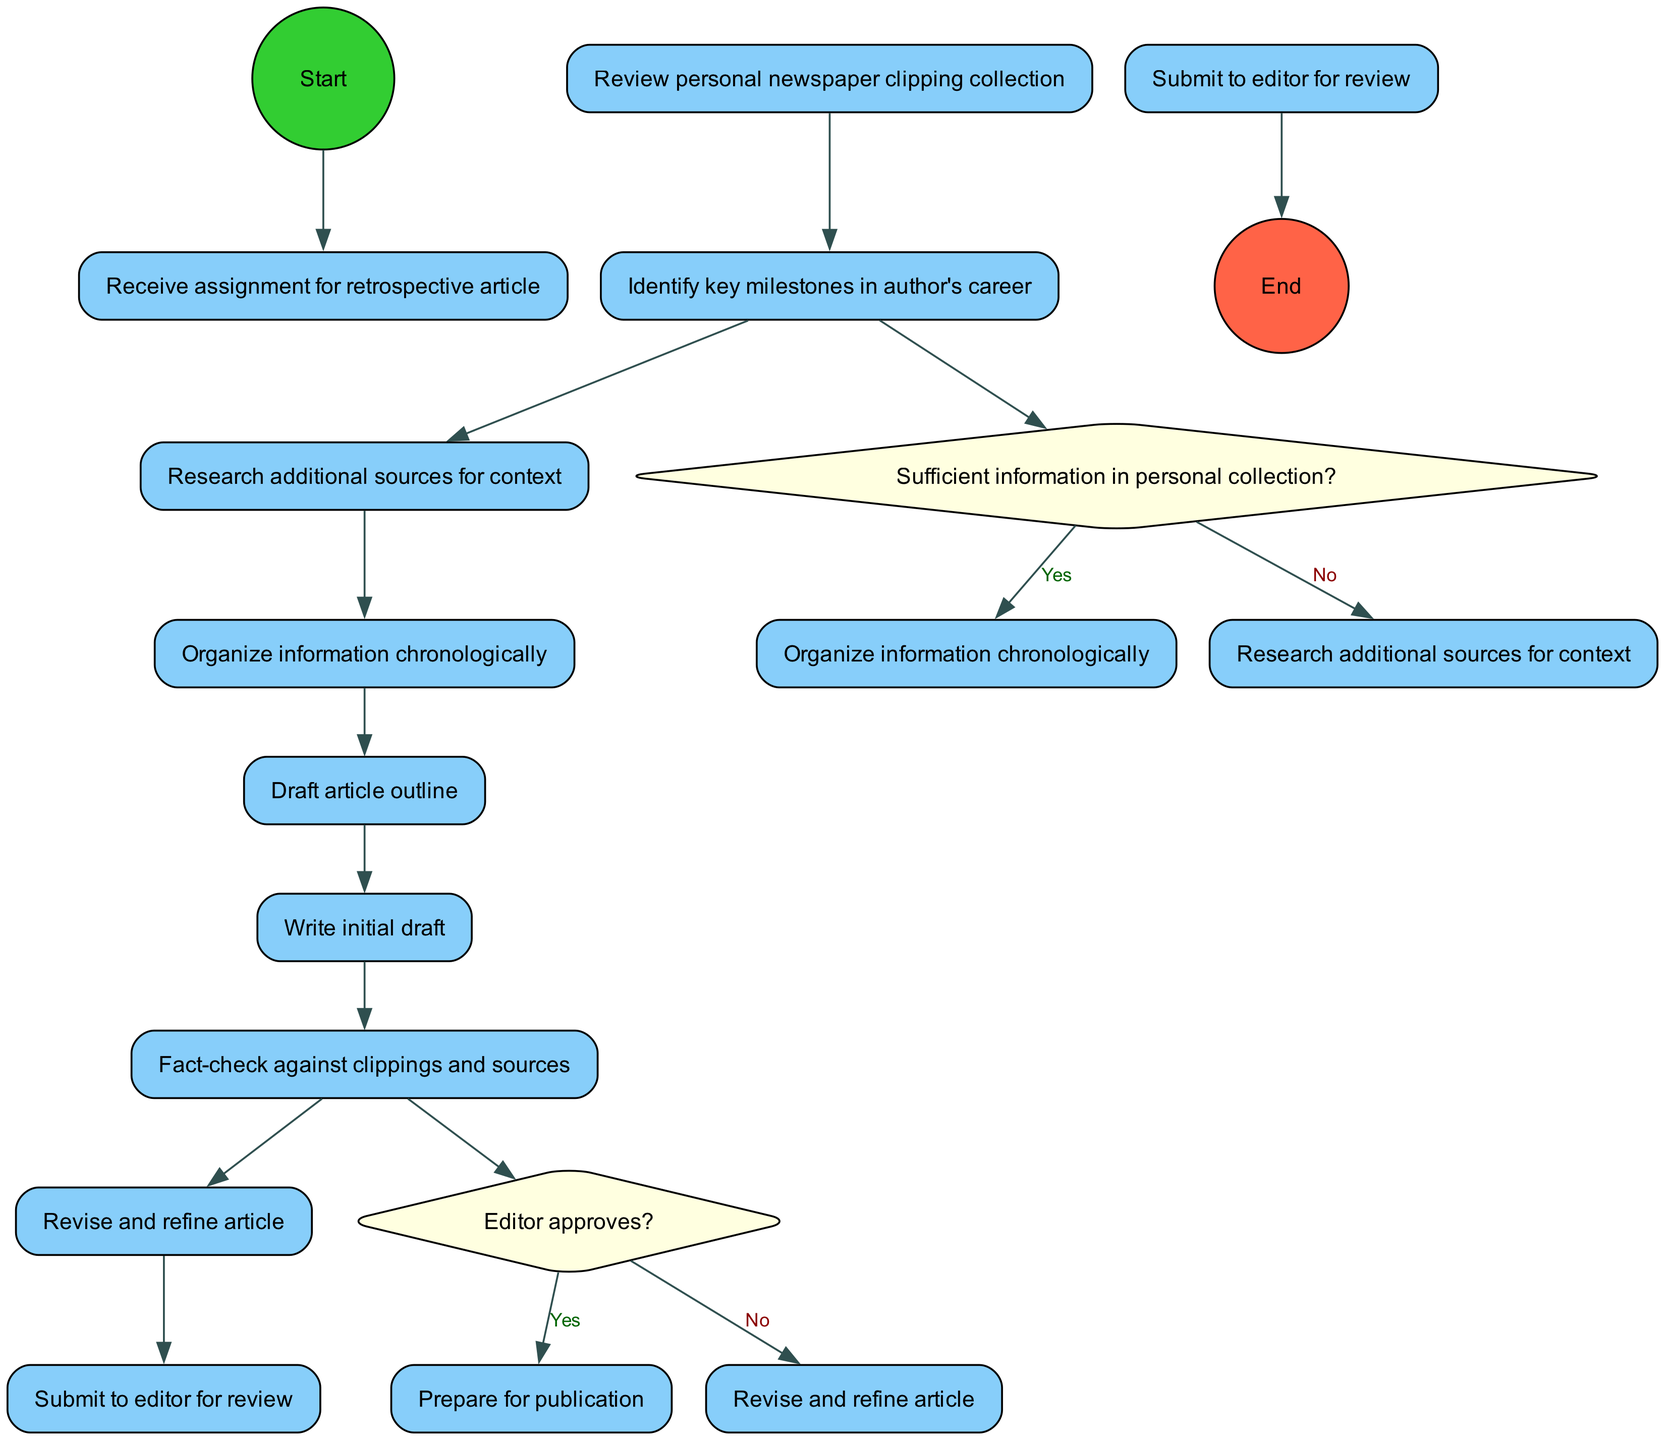What is the starting node of the diagram? The starting node is labeled "Receive assignment for retrospective article," which signifies the first step in the workflow.
Answer: Receive assignment for retrospective article How many activities are there in the workflow? There are nine activities listed in the diagram, each representing a distinct step in the process of writing the retrospective article.
Answer: 9 What is the first decision point in the diagram? The first decision point is the question "Sufficient information in personal collection?" which indicates whether to proceed with organizing the collected information or to research additional sources.
Answer: Sufficient information in personal collection? What happens if the editor does not approve the article? If the editor does not approve the article, the workflow directs the author to "Revise and refine article," indicating that changes must be made before resubmission.
Answer: Revise and refine article How does one handle insufficient information in the personal collection? If there is insufficient information in the personal collection, the author is directed to "Research additional sources for context," leading to further investigation before organizing the information.
Answer: Research additional sources for context What is the end node of the diagram? The end node is labeled "Article published," marking the final outcome of the workflow after completing all necessary steps and receiving approval from the editor.
Answer: Article published What comes after drafting the article outline? After drafting the article outline, the next step is to "Write initial draft," which involves creating the first version of the article based on the outline and research.
Answer: Write initial draft What decision follows after writing the initial draft? After writing the initial draft, a decision is made whether the editor approves the article, establishing a critical checkpoint in the article’s journey toward publication.
Answer: Editor approves? What is the last activity before the article is published? The last activity before the article is published is "Submit to editor for review," which signifies the submission of the finalized article to the editor for their approval.
Answer: Submit to editor for review 